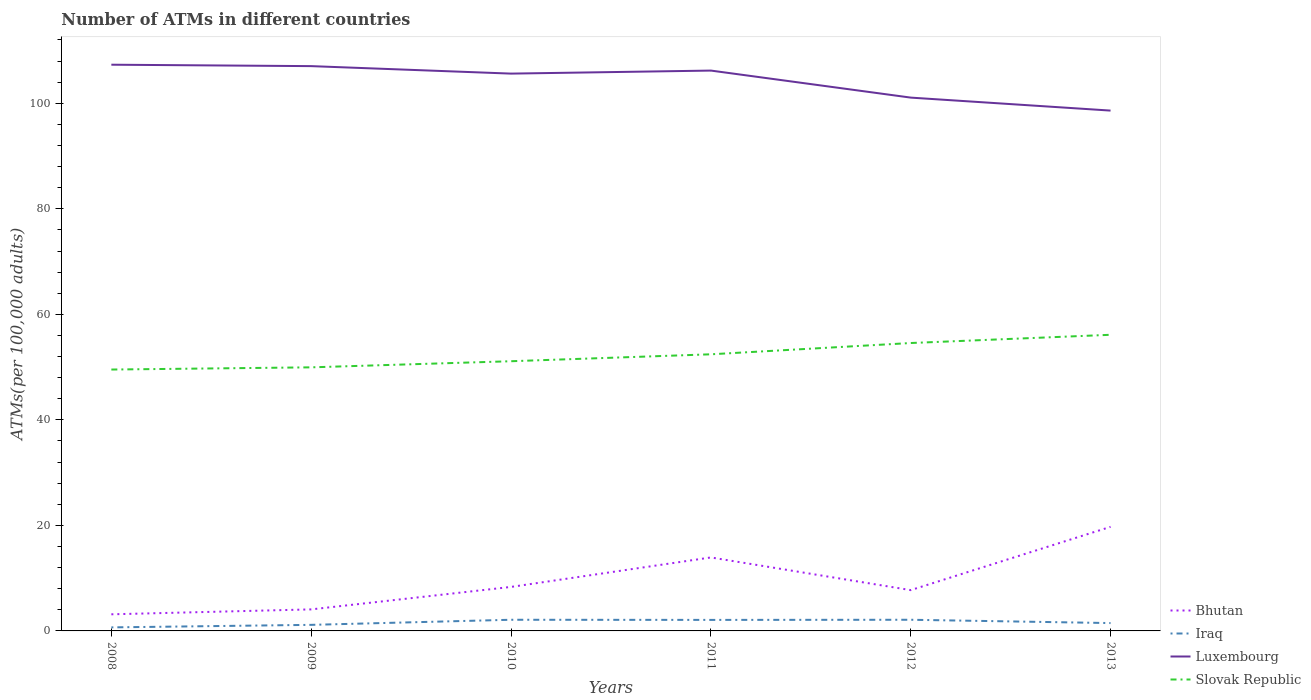How many different coloured lines are there?
Make the answer very short. 4. Does the line corresponding to Bhutan intersect with the line corresponding to Iraq?
Your answer should be very brief. No. Is the number of lines equal to the number of legend labels?
Give a very brief answer. Yes. Across all years, what is the maximum number of ATMs in Iraq?
Your response must be concise. 0.67. What is the total number of ATMs in Bhutan in the graph?
Your response must be concise. -11.39. What is the difference between the highest and the second highest number of ATMs in Iraq?
Make the answer very short. 1.45. Is the number of ATMs in Luxembourg strictly greater than the number of ATMs in Iraq over the years?
Keep it short and to the point. No. How many years are there in the graph?
Your answer should be compact. 6. Does the graph contain any zero values?
Give a very brief answer. No. Does the graph contain grids?
Provide a succinct answer. No. What is the title of the graph?
Give a very brief answer. Number of ATMs in different countries. Does "Italy" appear as one of the legend labels in the graph?
Ensure brevity in your answer.  No. What is the label or title of the X-axis?
Provide a short and direct response. Years. What is the label or title of the Y-axis?
Your response must be concise. ATMs(per 100,0 adults). What is the ATMs(per 100,000 adults) in Bhutan in 2008?
Offer a very short reply. 3.15. What is the ATMs(per 100,000 adults) in Iraq in 2008?
Provide a short and direct response. 0.67. What is the ATMs(per 100,000 adults) in Luxembourg in 2008?
Give a very brief answer. 107.32. What is the ATMs(per 100,000 adults) of Slovak Republic in 2008?
Offer a terse response. 49.54. What is the ATMs(per 100,000 adults) in Bhutan in 2009?
Your answer should be very brief. 4.08. What is the ATMs(per 100,000 adults) of Iraq in 2009?
Provide a succinct answer. 1.15. What is the ATMs(per 100,000 adults) of Luxembourg in 2009?
Your answer should be compact. 107.05. What is the ATMs(per 100,000 adults) in Slovak Republic in 2009?
Your answer should be very brief. 49.96. What is the ATMs(per 100,000 adults) in Bhutan in 2010?
Offer a very short reply. 8.34. What is the ATMs(per 100,000 adults) in Iraq in 2010?
Make the answer very short. 2.12. What is the ATMs(per 100,000 adults) of Luxembourg in 2010?
Keep it short and to the point. 105.63. What is the ATMs(per 100,000 adults) in Slovak Republic in 2010?
Provide a short and direct response. 51.12. What is the ATMs(per 100,000 adults) of Bhutan in 2011?
Provide a succinct answer. 13.93. What is the ATMs(per 100,000 adults) of Iraq in 2011?
Keep it short and to the point. 2.09. What is the ATMs(per 100,000 adults) in Luxembourg in 2011?
Make the answer very short. 106.2. What is the ATMs(per 100,000 adults) of Slovak Republic in 2011?
Your answer should be compact. 52.43. What is the ATMs(per 100,000 adults) in Bhutan in 2012?
Your answer should be very brief. 7.73. What is the ATMs(per 100,000 adults) in Iraq in 2012?
Your answer should be very brief. 2.12. What is the ATMs(per 100,000 adults) of Luxembourg in 2012?
Your response must be concise. 101.08. What is the ATMs(per 100,000 adults) in Slovak Republic in 2012?
Keep it short and to the point. 54.57. What is the ATMs(per 100,000 adults) in Bhutan in 2013?
Provide a short and direct response. 19.73. What is the ATMs(per 100,000 adults) in Iraq in 2013?
Provide a succinct answer. 1.49. What is the ATMs(per 100,000 adults) of Luxembourg in 2013?
Offer a very short reply. 98.62. What is the ATMs(per 100,000 adults) in Slovak Republic in 2013?
Your answer should be very brief. 56.13. Across all years, what is the maximum ATMs(per 100,000 adults) in Bhutan?
Give a very brief answer. 19.73. Across all years, what is the maximum ATMs(per 100,000 adults) of Iraq?
Give a very brief answer. 2.12. Across all years, what is the maximum ATMs(per 100,000 adults) in Luxembourg?
Provide a succinct answer. 107.32. Across all years, what is the maximum ATMs(per 100,000 adults) of Slovak Republic?
Ensure brevity in your answer.  56.13. Across all years, what is the minimum ATMs(per 100,000 adults) in Bhutan?
Your response must be concise. 3.15. Across all years, what is the minimum ATMs(per 100,000 adults) of Iraq?
Give a very brief answer. 0.67. Across all years, what is the minimum ATMs(per 100,000 adults) of Luxembourg?
Keep it short and to the point. 98.62. Across all years, what is the minimum ATMs(per 100,000 adults) in Slovak Republic?
Your response must be concise. 49.54. What is the total ATMs(per 100,000 adults) of Bhutan in the graph?
Provide a succinct answer. 56.96. What is the total ATMs(per 100,000 adults) of Iraq in the graph?
Give a very brief answer. 9.63. What is the total ATMs(per 100,000 adults) in Luxembourg in the graph?
Make the answer very short. 625.89. What is the total ATMs(per 100,000 adults) of Slovak Republic in the graph?
Provide a short and direct response. 313.74. What is the difference between the ATMs(per 100,000 adults) in Bhutan in 2008 and that in 2009?
Provide a succinct answer. -0.93. What is the difference between the ATMs(per 100,000 adults) in Iraq in 2008 and that in 2009?
Your response must be concise. -0.48. What is the difference between the ATMs(per 100,000 adults) of Luxembourg in 2008 and that in 2009?
Your answer should be very brief. 0.27. What is the difference between the ATMs(per 100,000 adults) of Slovak Republic in 2008 and that in 2009?
Your response must be concise. -0.42. What is the difference between the ATMs(per 100,000 adults) of Bhutan in 2008 and that in 2010?
Offer a terse response. -5.19. What is the difference between the ATMs(per 100,000 adults) of Iraq in 2008 and that in 2010?
Offer a very short reply. -1.45. What is the difference between the ATMs(per 100,000 adults) in Luxembourg in 2008 and that in 2010?
Your answer should be very brief. 1.69. What is the difference between the ATMs(per 100,000 adults) in Slovak Republic in 2008 and that in 2010?
Make the answer very short. -1.58. What is the difference between the ATMs(per 100,000 adults) in Bhutan in 2008 and that in 2011?
Make the answer very short. -10.78. What is the difference between the ATMs(per 100,000 adults) in Iraq in 2008 and that in 2011?
Your response must be concise. -1.42. What is the difference between the ATMs(per 100,000 adults) in Slovak Republic in 2008 and that in 2011?
Offer a terse response. -2.89. What is the difference between the ATMs(per 100,000 adults) of Bhutan in 2008 and that in 2012?
Provide a short and direct response. -4.58. What is the difference between the ATMs(per 100,000 adults) in Iraq in 2008 and that in 2012?
Provide a short and direct response. -1.45. What is the difference between the ATMs(per 100,000 adults) in Luxembourg in 2008 and that in 2012?
Offer a very short reply. 6.24. What is the difference between the ATMs(per 100,000 adults) of Slovak Republic in 2008 and that in 2012?
Provide a short and direct response. -5.03. What is the difference between the ATMs(per 100,000 adults) of Bhutan in 2008 and that in 2013?
Make the answer very short. -16.58. What is the difference between the ATMs(per 100,000 adults) in Iraq in 2008 and that in 2013?
Make the answer very short. -0.82. What is the difference between the ATMs(per 100,000 adults) in Luxembourg in 2008 and that in 2013?
Offer a very short reply. 8.7. What is the difference between the ATMs(per 100,000 adults) in Slovak Republic in 2008 and that in 2013?
Provide a succinct answer. -6.59. What is the difference between the ATMs(per 100,000 adults) of Bhutan in 2009 and that in 2010?
Give a very brief answer. -4.26. What is the difference between the ATMs(per 100,000 adults) in Iraq in 2009 and that in 2010?
Give a very brief answer. -0.97. What is the difference between the ATMs(per 100,000 adults) in Luxembourg in 2009 and that in 2010?
Make the answer very short. 1.42. What is the difference between the ATMs(per 100,000 adults) in Slovak Republic in 2009 and that in 2010?
Keep it short and to the point. -1.16. What is the difference between the ATMs(per 100,000 adults) in Bhutan in 2009 and that in 2011?
Your response must be concise. -9.84. What is the difference between the ATMs(per 100,000 adults) in Iraq in 2009 and that in 2011?
Offer a terse response. -0.94. What is the difference between the ATMs(per 100,000 adults) in Luxembourg in 2009 and that in 2011?
Make the answer very short. 0.84. What is the difference between the ATMs(per 100,000 adults) of Slovak Republic in 2009 and that in 2011?
Make the answer very short. -2.47. What is the difference between the ATMs(per 100,000 adults) in Bhutan in 2009 and that in 2012?
Offer a very short reply. -3.65. What is the difference between the ATMs(per 100,000 adults) in Iraq in 2009 and that in 2012?
Ensure brevity in your answer.  -0.97. What is the difference between the ATMs(per 100,000 adults) in Luxembourg in 2009 and that in 2012?
Provide a short and direct response. 5.97. What is the difference between the ATMs(per 100,000 adults) in Slovak Republic in 2009 and that in 2012?
Your response must be concise. -4.61. What is the difference between the ATMs(per 100,000 adults) in Bhutan in 2009 and that in 2013?
Your answer should be very brief. -15.65. What is the difference between the ATMs(per 100,000 adults) in Iraq in 2009 and that in 2013?
Offer a terse response. -0.34. What is the difference between the ATMs(per 100,000 adults) in Luxembourg in 2009 and that in 2013?
Your response must be concise. 8.43. What is the difference between the ATMs(per 100,000 adults) in Slovak Republic in 2009 and that in 2013?
Provide a short and direct response. -6.17. What is the difference between the ATMs(per 100,000 adults) of Bhutan in 2010 and that in 2011?
Ensure brevity in your answer.  -5.59. What is the difference between the ATMs(per 100,000 adults) of Iraq in 2010 and that in 2011?
Offer a very short reply. 0.03. What is the difference between the ATMs(per 100,000 adults) of Luxembourg in 2010 and that in 2011?
Your answer should be very brief. -0.58. What is the difference between the ATMs(per 100,000 adults) in Slovak Republic in 2010 and that in 2011?
Your response must be concise. -1.31. What is the difference between the ATMs(per 100,000 adults) in Bhutan in 2010 and that in 2012?
Ensure brevity in your answer.  0.61. What is the difference between the ATMs(per 100,000 adults) in Luxembourg in 2010 and that in 2012?
Your response must be concise. 4.55. What is the difference between the ATMs(per 100,000 adults) of Slovak Republic in 2010 and that in 2012?
Keep it short and to the point. -3.45. What is the difference between the ATMs(per 100,000 adults) in Bhutan in 2010 and that in 2013?
Ensure brevity in your answer.  -11.39. What is the difference between the ATMs(per 100,000 adults) of Iraq in 2010 and that in 2013?
Make the answer very short. 0.63. What is the difference between the ATMs(per 100,000 adults) of Luxembourg in 2010 and that in 2013?
Make the answer very short. 7.01. What is the difference between the ATMs(per 100,000 adults) of Slovak Republic in 2010 and that in 2013?
Your response must be concise. -5.01. What is the difference between the ATMs(per 100,000 adults) of Bhutan in 2011 and that in 2012?
Keep it short and to the point. 6.19. What is the difference between the ATMs(per 100,000 adults) of Iraq in 2011 and that in 2012?
Your response must be concise. -0.03. What is the difference between the ATMs(per 100,000 adults) in Luxembourg in 2011 and that in 2012?
Keep it short and to the point. 5.12. What is the difference between the ATMs(per 100,000 adults) of Slovak Republic in 2011 and that in 2012?
Provide a succinct answer. -2.14. What is the difference between the ATMs(per 100,000 adults) in Bhutan in 2011 and that in 2013?
Your answer should be very brief. -5.8. What is the difference between the ATMs(per 100,000 adults) in Iraq in 2011 and that in 2013?
Offer a very short reply. 0.6. What is the difference between the ATMs(per 100,000 adults) of Luxembourg in 2011 and that in 2013?
Make the answer very short. 7.58. What is the difference between the ATMs(per 100,000 adults) of Slovak Republic in 2011 and that in 2013?
Your answer should be compact. -3.7. What is the difference between the ATMs(per 100,000 adults) of Bhutan in 2012 and that in 2013?
Your answer should be very brief. -11.99. What is the difference between the ATMs(per 100,000 adults) in Iraq in 2012 and that in 2013?
Ensure brevity in your answer.  0.63. What is the difference between the ATMs(per 100,000 adults) of Luxembourg in 2012 and that in 2013?
Provide a short and direct response. 2.46. What is the difference between the ATMs(per 100,000 adults) in Slovak Republic in 2012 and that in 2013?
Your answer should be compact. -1.56. What is the difference between the ATMs(per 100,000 adults) in Bhutan in 2008 and the ATMs(per 100,000 adults) in Luxembourg in 2009?
Offer a terse response. -103.9. What is the difference between the ATMs(per 100,000 adults) in Bhutan in 2008 and the ATMs(per 100,000 adults) in Slovak Republic in 2009?
Give a very brief answer. -46.81. What is the difference between the ATMs(per 100,000 adults) of Iraq in 2008 and the ATMs(per 100,000 adults) of Luxembourg in 2009?
Offer a terse response. -106.38. What is the difference between the ATMs(per 100,000 adults) of Iraq in 2008 and the ATMs(per 100,000 adults) of Slovak Republic in 2009?
Provide a short and direct response. -49.29. What is the difference between the ATMs(per 100,000 adults) of Luxembourg in 2008 and the ATMs(per 100,000 adults) of Slovak Republic in 2009?
Make the answer very short. 57.36. What is the difference between the ATMs(per 100,000 adults) of Bhutan in 2008 and the ATMs(per 100,000 adults) of Iraq in 2010?
Your response must be concise. 1.03. What is the difference between the ATMs(per 100,000 adults) in Bhutan in 2008 and the ATMs(per 100,000 adults) in Luxembourg in 2010?
Keep it short and to the point. -102.48. What is the difference between the ATMs(per 100,000 adults) in Bhutan in 2008 and the ATMs(per 100,000 adults) in Slovak Republic in 2010?
Give a very brief answer. -47.97. What is the difference between the ATMs(per 100,000 adults) of Iraq in 2008 and the ATMs(per 100,000 adults) of Luxembourg in 2010?
Make the answer very short. -104.96. What is the difference between the ATMs(per 100,000 adults) in Iraq in 2008 and the ATMs(per 100,000 adults) in Slovak Republic in 2010?
Ensure brevity in your answer.  -50.45. What is the difference between the ATMs(per 100,000 adults) in Luxembourg in 2008 and the ATMs(per 100,000 adults) in Slovak Republic in 2010?
Your response must be concise. 56.2. What is the difference between the ATMs(per 100,000 adults) in Bhutan in 2008 and the ATMs(per 100,000 adults) in Iraq in 2011?
Provide a succinct answer. 1.06. What is the difference between the ATMs(per 100,000 adults) of Bhutan in 2008 and the ATMs(per 100,000 adults) of Luxembourg in 2011?
Give a very brief answer. -103.05. What is the difference between the ATMs(per 100,000 adults) in Bhutan in 2008 and the ATMs(per 100,000 adults) in Slovak Republic in 2011?
Provide a short and direct response. -49.28. What is the difference between the ATMs(per 100,000 adults) in Iraq in 2008 and the ATMs(per 100,000 adults) in Luxembourg in 2011?
Your answer should be compact. -105.53. What is the difference between the ATMs(per 100,000 adults) in Iraq in 2008 and the ATMs(per 100,000 adults) in Slovak Republic in 2011?
Make the answer very short. -51.76. What is the difference between the ATMs(per 100,000 adults) of Luxembourg in 2008 and the ATMs(per 100,000 adults) of Slovak Republic in 2011?
Ensure brevity in your answer.  54.89. What is the difference between the ATMs(per 100,000 adults) of Bhutan in 2008 and the ATMs(per 100,000 adults) of Iraq in 2012?
Keep it short and to the point. 1.03. What is the difference between the ATMs(per 100,000 adults) of Bhutan in 2008 and the ATMs(per 100,000 adults) of Luxembourg in 2012?
Give a very brief answer. -97.93. What is the difference between the ATMs(per 100,000 adults) of Bhutan in 2008 and the ATMs(per 100,000 adults) of Slovak Republic in 2012?
Your response must be concise. -51.42. What is the difference between the ATMs(per 100,000 adults) in Iraq in 2008 and the ATMs(per 100,000 adults) in Luxembourg in 2012?
Offer a very short reply. -100.41. What is the difference between the ATMs(per 100,000 adults) in Iraq in 2008 and the ATMs(per 100,000 adults) in Slovak Republic in 2012?
Your response must be concise. -53.9. What is the difference between the ATMs(per 100,000 adults) in Luxembourg in 2008 and the ATMs(per 100,000 adults) in Slovak Republic in 2012?
Provide a short and direct response. 52.75. What is the difference between the ATMs(per 100,000 adults) in Bhutan in 2008 and the ATMs(per 100,000 adults) in Iraq in 2013?
Your answer should be compact. 1.66. What is the difference between the ATMs(per 100,000 adults) in Bhutan in 2008 and the ATMs(per 100,000 adults) in Luxembourg in 2013?
Ensure brevity in your answer.  -95.47. What is the difference between the ATMs(per 100,000 adults) in Bhutan in 2008 and the ATMs(per 100,000 adults) in Slovak Republic in 2013?
Make the answer very short. -52.98. What is the difference between the ATMs(per 100,000 adults) of Iraq in 2008 and the ATMs(per 100,000 adults) of Luxembourg in 2013?
Provide a short and direct response. -97.95. What is the difference between the ATMs(per 100,000 adults) of Iraq in 2008 and the ATMs(per 100,000 adults) of Slovak Republic in 2013?
Your response must be concise. -55.46. What is the difference between the ATMs(per 100,000 adults) of Luxembourg in 2008 and the ATMs(per 100,000 adults) of Slovak Republic in 2013?
Offer a terse response. 51.19. What is the difference between the ATMs(per 100,000 adults) of Bhutan in 2009 and the ATMs(per 100,000 adults) of Iraq in 2010?
Keep it short and to the point. 1.97. What is the difference between the ATMs(per 100,000 adults) of Bhutan in 2009 and the ATMs(per 100,000 adults) of Luxembourg in 2010?
Provide a succinct answer. -101.55. What is the difference between the ATMs(per 100,000 adults) of Bhutan in 2009 and the ATMs(per 100,000 adults) of Slovak Republic in 2010?
Your answer should be compact. -47.03. What is the difference between the ATMs(per 100,000 adults) of Iraq in 2009 and the ATMs(per 100,000 adults) of Luxembourg in 2010?
Offer a very short reply. -104.48. What is the difference between the ATMs(per 100,000 adults) in Iraq in 2009 and the ATMs(per 100,000 adults) in Slovak Republic in 2010?
Give a very brief answer. -49.97. What is the difference between the ATMs(per 100,000 adults) in Luxembourg in 2009 and the ATMs(per 100,000 adults) in Slovak Republic in 2010?
Ensure brevity in your answer.  55.93. What is the difference between the ATMs(per 100,000 adults) in Bhutan in 2009 and the ATMs(per 100,000 adults) in Iraq in 2011?
Provide a short and direct response. 1.99. What is the difference between the ATMs(per 100,000 adults) of Bhutan in 2009 and the ATMs(per 100,000 adults) of Luxembourg in 2011?
Offer a terse response. -102.12. What is the difference between the ATMs(per 100,000 adults) of Bhutan in 2009 and the ATMs(per 100,000 adults) of Slovak Republic in 2011?
Provide a succinct answer. -48.35. What is the difference between the ATMs(per 100,000 adults) of Iraq in 2009 and the ATMs(per 100,000 adults) of Luxembourg in 2011?
Give a very brief answer. -105.05. What is the difference between the ATMs(per 100,000 adults) in Iraq in 2009 and the ATMs(per 100,000 adults) in Slovak Republic in 2011?
Your answer should be very brief. -51.28. What is the difference between the ATMs(per 100,000 adults) of Luxembourg in 2009 and the ATMs(per 100,000 adults) of Slovak Republic in 2011?
Offer a terse response. 54.62. What is the difference between the ATMs(per 100,000 adults) in Bhutan in 2009 and the ATMs(per 100,000 adults) in Iraq in 2012?
Offer a very short reply. 1.97. What is the difference between the ATMs(per 100,000 adults) of Bhutan in 2009 and the ATMs(per 100,000 adults) of Luxembourg in 2012?
Keep it short and to the point. -97. What is the difference between the ATMs(per 100,000 adults) of Bhutan in 2009 and the ATMs(per 100,000 adults) of Slovak Republic in 2012?
Provide a short and direct response. -50.48. What is the difference between the ATMs(per 100,000 adults) of Iraq in 2009 and the ATMs(per 100,000 adults) of Luxembourg in 2012?
Give a very brief answer. -99.93. What is the difference between the ATMs(per 100,000 adults) of Iraq in 2009 and the ATMs(per 100,000 adults) of Slovak Republic in 2012?
Offer a very short reply. -53.42. What is the difference between the ATMs(per 100,000 adults) in Luxembourg in 2009 and the ATMs(per 100,000 adults) in Slovak Republic in 2012?
Ensure brevity in your answer.  52.48. What is the difference between the ATMs(per 100,000 adults) in Bhutan in 2009 and the ATMs(per 100,000 adults) in Iraq in 2013?
Ensure brevity in your answer.  2.59. What is the difference between the ATMs(per 100,000 adults) of Bhutan in 2009 and the ATMs(per 100,000 adults) of Luxembourg in 2013?
Your answer should be compact. -94.54. What is the difference between the ATMs(per 100,000 adults) in Bhutan in 2009 and the ATMs(per 100,000 adults) in Slovak Republic in 2013?
Provide a succinct answer. -52.05. What is the difference between the ATMs(per 100,000 adults) in Iraq in 2009 and the ATMs(per 100,000 adults) in Luxembourg in 2013?
Keep it short and to the point. -97.47. What is the difference between the ATMs(per 100,000 adults) of Iraq in 2009 and the ATMs(per 100,000 adults) of Slovak Republic in 2013?
Offer a very short reply. -54.98. What is the difference between the ATMs(per 100,000 adults) in Luxembourg in 2009 and the ATMs(per 100,000 adults) in Slovak Republic in 2013?
Your answer should be very brief. 50.92. What is the difference between the ATMs(per 100,000 adults) in Bhutan in 2010 and the ATMs(per 100,000 adults) in Iraq in 2011?
Ensure brevity in your answer.  6.25. What is the difference between the ATMs(per 100,000 adults) of Bhutan in 2010 and the ATMs(per 100,000 adults) of Luxembourg in 2011?
Your response must be concise. -97.86. What is the difference between the ATMs(per 100,000 adults) in Bhutan in 2010 and the ATMs(per 100,000 adults) in Slovak Republic in 2011?
Offer a terse response. -44.09. What is the difference between the ATMs(per 100,000 adults) in Iraq in 2010 and the ATMs(per 100,000 adults) in Luxembourg in 2011?
Your response must be concise. -104.09. What is the difference between the ATMs(per 100,000 adults) of Iraq in 2010 and the ATMs(per 100,000 adults) of Slovak Republic in 2011?
Offer a terse response. -50.31. What is the difference between the ATMs(per 100,000 adults) in Luxembourg in 2010 and the ATMs(per 100,000 adults) in Slovak Republic in 2011?
Provide a succinct answer. 53.2. What is the difference between the ATMs(per 100,000 adults) of Bhutan in 2010 and the ATMs(per 100,000 adults) of Iraq in 2012?
Offer a very short reply. 6.22. What is the difference between the ATMs(per 100,000 adults) of Bhutan in 2010 and the ATMs(per 100,000 adults) of Luxembourg in 2012?
Your answer should be very brief. -92.74. What is the difference between the ATMs(per 100,000 adults) in Bhutan in 2010 and the ATMs(per 100,000 adults) in Slovak Republic in 2012?
Your response must be concise. -46.23. What is the difference between the ATMs(per 100,000 adults) in Iraq in 2010 and the ATMs(per 100,000 adults) in Luxembourg in 2012?
Give a very brief answer. -98.96. What is the difference between the ATMs(per 100,000 adults) in Iraq in 2010 and the ATMs(per 100,000 adults) in Slovak Republic in 2012?
Offer a terse response. -52.45. What is the difference between the ATMs(per 100,000 adults) in Luxembourg in 2010 and the ATMs(per 100,000 adults) in Slovak Republic in 2012?
Keep it short and to the point. 51.06. What is the difference between the ATMs(per 100,000 adults) of Bhutan in 2010 and the ATMs(per 100,000 adults) of Iraq in 2013?
Make the answer very short. 6.85. What is the difference between the ATMs(per 100,000 adults) in Bhutan in 2010 and the ATMs(per 100,000 adults) in Luxembourg in 2013?
Make the answer very short. -90.28. What is the difference between the ATMs(per 100,000 adults) in Bhutan in 2010 and the ATMs(per 100,000 adults) in Slovak Republic in 2013?
Your answer should be very brief. -47.79. What is the difference between the ATMs(per 100,000 adults) in Iraq in 2010 and the ATMs(per 100,000 adults) in Luxembourg in 2013?
Make the answer very short. -96.5. What is the difference between the ATMs(per 100,000 adults) of Iraq in 2010 and the ATMs(per 100,000 adults) of Slovak Republic in 2013?
Offer a very short reply. -54.01. What is the difference between the ATMs(per 100,000 adults) in Luxembourg in 2010 and the ATMs(per 100,000 adults) in Slovak Republic in 2013?
Give a very brief answer. 49.5. What is the difference between the ATMs(per 100,000 adults) in Bhutan in 2011 and the ATMs(per 100,000 adults) in Iraq in 2012?
Offer a very short reply. 11.81. What is the difference between the ATMs(per 100,000 adults) of Bhutan in 2011 and the ATMs(per 100,000 adults) of Luxembourg in 2012?
Provide a succinct answer. -87.15. What is the difference between the ATMs(per 100,000 adults) in Bhutan in 2011 and the ATMs(per 100,000 adults) in Slovak Republic in 2012?
Your answer should be very brief. -40.64. What is the difference between the ATMs(per 100,000 adults) of Iraq in 2011 and the ATMs(per 100,000 adults) of Luxembourg in 2012?
Your answer should be very brief. -98.99. What is the difference between the ATMs(per 100,000 adults) of Iraq in 2011 and the ATMs(per 100,000 adults) of Slovak Republic in 2012?
Ensure brevity in your answer.  -52.48. What is the difference between the ATMs(per 100,000 adults) in Luxembourg in 2011 and the ATMs(per 100,000 adults) in Slovak Republic in 2012?
Your answer should be compact. 51.64. What is the difference between the ATMs(per 100,000 adults) of Bhutan in 2011 and the ATMs(per 100,000 adults) of Iraq in 2013?
Your answer should be compact. 12.44. What is the difference between the ATMs(per 100,000 adults) of Bhutan in 2011 and the ATMs(per 100,000 adults) of Luxembourg in 2013?
Your answer should be very brief. -84.69. What is the difference between the ATMs(per 100,000 adults) in Bhutan in 2011 and the ATMs(per 100,000 adults) in Slovak Republic in 2013?
Make the answer very short. -42.2. What is the difference between the ATMs(per 100,000 adults) of Iraq in 2011 and the ATMs(per 100,000 adults) of Luxembourg in 2013?
Your response must be concise. -96.53. What is the difference between the ATMs(per 100,000 adults) in Iraq in 2011 and the ATMs(per 100,000 adults) in Slovak Republic in 2013?
Provide a succinct answer. -54.04. What is the difference between the ATMs(per 100,000 adults) in Luxembourg in 2011 and the ATMs(per 100,000 adults) in Slovak Republic in 2013?
Keep it short and to the point. 50.08. What is the difference between the ATMs(per 100,000 adults) of Bhutan in 2012 and the ATMs(per 100,000 adults) of Iraq in 2013?
Your answer should be compact. 6.25. What is the difference between the ATMs(per 100,000 adults) in Bhutan in 2012 and the ATMs(per 100,000 adults) in Luxembourg in 2013?
Provide a succinct answer. -90.89. What is the difference between the ATMs(per 100,000 adults) in Bhutan in 2012 and the ATMs(per 100,000 adults) in Slovak Republic in 2013?
Offer a terse response. -48.39. What is the difference between the ATMs(per 100,000 adults) in Iraq in 2012 and the ATMs(per 100,000 adults) in Luxembourg in 2013?
Make the answer very short. -96.5. What is the difference between the ATMs(per 100,000 adults) of Iraq in 2012 and the ATMs(per 100,000 adults) of Slovak Republic in 2013?
Your answer should be compact. -54.01. What is the difference between the ATMs(per 100,000 adults) in Luxembourg in 2012 and the ATMs(per 100,000 adults) in Slovak Republic in 2013?
Offer a terse response. 44.95. What is the average ATMs(per 100,000 adults) of Bhutan per year?
Keep it short and to the point. 9.49. What is the average ATMs(per 100,000 adults) in Iraq per year?
Provide a succinct answer. 1.6. What is the average ATMs(per 100,000 adults) in Luxembourg per year?
Your answer should be compact. 104.32. What is the average ATMs(per 100,000 adults) in Slovak Republic per year?
Ensure brevity in your answer.  52.29. In the year 2008, what is the difference between the ATMs(per 100,000 adults) of Bhutan and ATMs(per 100,000 adults) of Iraq?
Your answer should be very brief. 2.48. In the year 2008, what is the difference between the ATMs(per 100,000 adults) of Bhutan and ATMs(per 100,000 adults) of Luxembourg?
Make the answer very short. -104.17. In the year 2008, what is the difference between the ATMs(per 100,000 adults) of Bhutan and ATMs(per 100,000 adults) of Slovak Republic?
Offer a very short reply. -46.39. In the year 2008, what is the difference between the ATMs(per 100,000 adults) in Iraq and ATMs(per 100,000 adults) in Luxembourg?
Make the answer very short. -106.65. In the year 2008, what is the difference between the ATMs(per 100,000 adults) of Iraq and ATMs(per 100,000 adults) of Slovak Republic?
Offer a terse response. -48.87. In the year 2008, what is the difference between the ATMs(per 100,000 adults) of Luxembourg and ATMs(per 100,000 adults) of Slovak Republic?
Provide a short and direct response. 57.78. In the year 2009, what is the difference between the ATMs(per 100,000 adults) of Bhutan and ATMs(per 100,000 adults) of Iraq?
Give a very brief answer. 2.93. In the year 2009, what is the difference between the ATMs(per 100,000 adults) of Bhutan and ATMs(per 100,000 adults) of Luxembourg?
Offer a very short reply. -102.96. In the year 2009, what is the difference between the ATMs(per 100,000 adults) of Bhutan and ATMs(per 100,000 adults) of Slovak Republic?
Offer a terse response. -45.88. In the year 2009, what is the difference between the ATMs(per 100,000 adults) in Iraq and ATMs(per 100,000 adults) in Luxembourg?
Offer a very short reply. -105.9. In the year 2009, what is the difference between the ATMs(per 100,000 adults) of Iraq and ATMs(per 100,000 adults) of Slovak Republic?
Provide a short and direct response. -48.81. In the year 2009, what is the difference between the ATMs(per 100,000 adults) of Luxembourg and ATMs(per 100,000 adults) of Slovak Republic?
Offer a terse response. 57.09. In the year 2010, what is the difference between the ATMs(per 100,000 adults) of Bhutan and ATMs(per 100,000 adults) of Iraq?
Make the answer very short. 6.22. In the year 2010, what is the difference between the ATMs(per 100,000 adults) in Bhutan and ATMs(per 100,000 adults) in Luxembourg?
Your response must be concise. -97.29. In the year 2010, what is the difference between the ATMs(per 100,000 adults) of Bhutan and ATMs(per 100,000 adults) of Slovak Republic?
Provide a succinct answer. -42.78. In the year 2010, what is the difference between the ATMs(per 100,000 adults) of Iraq and ATMs(per 100,000 adults) of Luxembourg?
Your answer should be compact. -103.51. In the year 2010, what is the difference between the ATMs(per 100,000 adults) in Iraq and ATMs(per 100,000 adults) in Slovak Republic?
Make the answer very short. -49. In the year 2010, what is the difference between the ATMs(per 100,000 adults) in Luxembourg and ATMs(per 100,000 adults) in Slovak Republic?
Keep it short and to the point. 54.51. In the year 2011, what is the difference between the ATMs(per 100,000 adults) of Bhutan and ATMs(per 100,000 adults) of Iraq?
Give a very brief answer. 11.84. In the year 2011, what is the difference between the ATMs(per 100,000 adults) in Bhutan and ATMs(per 100,000 adults) in Luxembourg?
Your response must be concise. -92.28. In the year 2011, what is the difference between the ATMs(per 100,000 adults) in Bhutan and ATMs(per 100,000 adults) in Slovak Republic?
Give a very brief answer. -38.5. In the year 2011, what is the difference between the ATMs(per 100,000 adults) of Iraq and ATMs(per 100,000 adults) of Luxembourg?
Your response must be concise. -104.12. In the year 2011, what is the difference between the ATMs(per 100,000 adults) in Iraq and ATMs(per 100,000 adults) in Slovak Republic?
Ensure brevity in your answer.  -50.34. In the year 2011, what is the difference between the ATMs(per 100,000 adults) of Luxembourg and ATMs(per 100,000 adults) of Slovak Republic?
Keep it short and to the point. 53.77. In the year 2012, what is the difference between the ATMs(per 100,000 adults) in Bhutan and ATMs(per 100,000 adults) in Iraq?
Make the answer very short. 5.62. In the year 2012, what is the difference between the ATMs(per 100,000 adults) of Bhutan and ATMs(per 100,000 adults) of Luxembourg?
Keep it short and to the point. -93.35. In the year 2012, what is the difference between the ATMs(per 100,000 adults) in Bhutan and ATMs(per 100,000 adults) in Slovak Republic?
Make the answer very short. -46.83. In the year 2012, what is the difference between the ATMs(per 100,000 adults) in Iraq and ATMs(per 100,000 adults) in Luxembourg?
Your response must be concise. -98.96. In the year 2012, what is the difference between the ATMs(per 100,000 adults) of Iraq and ATMs(per 100,000 adults) of Slovak Republic?
Provide a short and direct response. -52.45. In the year 2012, what is the difference between the ATMs(per 100,000 adults) of Luxembourg and ATMs(per 100,000 adults) of Slovak Republic?
Your answer should be compact. 46.51. In the year 2013, what is the difference between the ATMs(per 100,000 adults) in Bhutan and ATMs(per 100,000 adults) in Iraq?
Your response must be concise. 18.24. In the year 2013, what is the difference between the ATMs(per 100,000 adults) in Bhutan and ATMs(per 100,000 adults) in Luxembourg?
Keep it short and to the point. -78.89. In the year 2013, what is the difference between the ATMs(per 100,000 adults) of Bhutan and ATMs(per 100,000 adults) of Slovak Republic?
Provide a short and direct response. -36.4. In the year 2013, what is the difference between the ATMs(per 100,000 adults) of Iraq and ATMs(per 100,000 adults) of Luxembourg?
Provide a succinct answer. -97.13. In the year 2013, what is the difference between the ATMs(per 100,000 adults) of Iraq and ATMs(per 100,000 adults) of Slovak Republic?
Make the answer very short. -54.64. In the year 2013, what is the difference between the ATMs(per 100,000 adults) in Luxembourg and ATMs(per 100,000 adults) in Slovak Republic?
Provide a short and direct response. 42.49. What is the ratio of the ATMs(per 100,000 adults) in Bhutan in 2008 to that in 2009?
Offer a very short reply. 0.77. What is the ratio of the ATMs(per 100,000 adults) in Iraq in 2008 to that in 2009?
Provide a short and direct response. 0.58. What is the ratio of the ATMs(per 100,000 adults) in Luxembourg in 2008 to that in 2009?
Ensure brevity in your answer.  1. What is the ratio of the ATMs(per 100,000 adults) in Bhutan in 2008 to that in 2010?
Your answer should be compact. 0.38. What is the ratio of the ATMs(per 100,000 adults) of Iraq in 2008 to that in 2010?
Ensure brevity in your answer.  0.32. What is the ratio of the ATMs(per 100,000 adults) of Luxembourg in 2008 to that in 2010?
Provide a short and direct response. 1.02. What is the ratio of the ATMs(per 100,000 adults) in Slovak Republic in 2008 to that in 2010?
Your answer should be very brief. 0.97. What is the ratio of the ATMs(per 100,000 adults) in Bhutan in 2008 to that in 2011?
Your answer should be compact. 0.23. What is the ratio of the ATMs(per 100,000 adults) of Iraq in 2008 to that in 2011?
Provide a short and direct response. 0.32. What is the ratio of the ATMs(per 100,000 adults) in Luxembourg in 2008 to that in 2011?
Your answer should be compact. 1.01. What is the ratio of the ATMs(per 100,000 adults) of Slovak Republic in 2008 to that in 2011?
Offer a very short reply. 0.94. What is the ratio of the ATMs(per 100,000 adults) of Bhutan in 2008 to that in 2012?
Provide a succinct answer. 0.41. What is the ratio of the ATMs(per 100,000 adults) in Iraq in 2008 to that in 2012?
Ensure brevity in your answer.  0.32. What is the ratio of the ATMs(per 100,000 adults) in Luxembourg in 2008 to that in 2012?
Ensure brevity in your answer.  1.06. What is the ratio of the ATMs(per 100,000 adults) in Slovak Republic in 2008 to that in 2012?
Keep it short and to the point. 0.91. What is the ratio of the ATMs(per 100,000 adults) of Bhutan in 2008 to that in 2013?
Make the answer very short. 0.16. What is the ratio of the ATMs(per 100,000 adults) of Iraq in 2008 to that in 2013?
Provide a short and direct response. 0.45. What is the ratio of the ATMs(per 100,000 adults) in Luxembourg in 2008 to that in 2013?
Your response must be concise. 1.09. What is the ratio of the ATMs(per 100,000 adults) of Slovak Republic in 2008 to that in 2013?
Your answer should be compact. 0.88. What is the ratio of the ATMs(per 100,000 adults) of Bhutan in 2009 to that in 2010?
Your response must be concise. 0.49. What is the ratio of the ATMs(per 100,000 adults) in Iraq in 2009 to that in 2010?
Provide a short and direct response. 0.54. What is the ratio of the ATMs(per 100,000 adults) of Luxembourg in 2009 to that in 2010?
Give a very brief answer. 1.01. What is the ratio of the ATMs(per 100,000 adults) in Slovak Republic in 2009 to that in 2010?
Offer a very short reply. 0.98. What is the ratio of the ATMs(per 100,000 adults) of Bhutan in 2009 to that in 2011?
Your answer should be compact. 0.29. What is the ratio of the ATMs(per 100,000 adults) in Iraq in 2009 to that in 2011?
Provide a short and direct response. 0.55. What is the ratio of the ATMs(per 100,000 adults) in Luxembourg in 2009 to that in 2011?
Provide a succinct answer. 1.01. What is the ratio of the ATMs(per 100,000 adults) of Slovak Republic in 2009 to that in 2011?
Offer a very short reply. 0.95. What is the ratio of the ATMs(per 100,000 adults) of Bhutan in 2009 to that in 2012?
Offer a terse response. 0.53. What is the ratio of the ATMs(per 100,000 adults) in Iraq in 2009 to that in 2012?
Offer a very short reply. 0.54. What is the ratio of the ATMs(per 100,000 adults) in Luxembourg in 2009 to that in 2012?
Provide a succinct answer. 1.06. What is the ratio of the ATMs(per 100,000 adults) in Slovak Republic in 2009 to that in 2012?
Provide a short and direct response. 0.92. What is the ratio of the ATMs(per 100,000 adults) of Bhutan in 2009 to that in 2013?
Provide a succinct answer. 0.21. What is the ratio of the ATMs(per 100,000 adults) in Iraq in 2009 to that in 2013?
Your answer should be compact. 0.77. What is the ratio of the ATMs(per 100,000 adults) in Luxembourg in 2009 to that in 2013?
Your response must be concise. 1.09. What is the ratio of the ATMs(per 100,000 adults) in Slovak Republic in 2009 to that in 2013?
Provide a short and direct response. 0.89. What is the ratio of the ATMs(per 100,000 adults) in Bhutan in 2010 to that in 2011?
Provide a succinct answer. 0.6. What is the ratio of the ATMs(per 100,000 adults) in Iraq in 2010 to that in 2011?
Ensure brevity in your answer.  1.01. What is the ratio of the ATMs(per 100,000 adults) of Slovak Republic in 2010 to that in 2011?
Offer a very short reply. 0.97. What is the ratio of the ATMs(per 100,000 adults) of Bhutan in 2010 to that in 2012?
Keep it short and to the point. 1.08. What is the ratio of the ATMs(per 100,000 adults) of Iraq in 2010 to that in 2012?
Provide a short and direct response. 1. What is the ratio of the ATMs(per 100,000 adults) of Luxembourg in 2010 to that in 2012?
Give a very brief answer. 1.04. What is the ratio of the ATMs(per 100,000 adults) in Slovak Republic in 2010 to that in 2012?
Your answer should be very brief. 0.94. What is the ratio of the ATMs(per 100,000 adults) of Bhutan in 2010 to that in 2013?
Make the answer very short. 0.42. What is the ratio of the ATMs(per 100,000 adults) of Iraq in 2010 to that in 2013?
Make the answer very short. 1.42. What is the ratio of the ATMs(per 100,000 adults) of Luxembourg in 2010 to that in 2013?
Offer a terse response. 1.07. What is the ratio of the ATMs(per 100,000 adults) in Slovak Republic in 2010 to that in 2013?
Offer a terse response. 0.91. What is the ratio of the ATMs(per 100,000 adults) in Bhutan in 2011 to that in 2012?
Keep it short and to the point. 1.8. What is the ratio of the ATMs(per 100,000 adults) in Iraq in 2011 to that in 2012?
Your response must be concise. 0.99. What is the ratio of the ATMs(per 100,000 adults) in Luxembourg in 2011 to that in 2012?
Your answer should be compact. 1.05. What is the ratio of the ATMs(per 100,000 adults) of Slovak Republic in 2011 to that in 2012?
Offer a terse response. 0.96. What is the ratio of the ATMs(per 100,000 adults) of Bhutan in 2011 to that in 2013?
Ensure brevity in your answer.  0.71. What is the ratio of the ATMs(per 100,000 adults) of Iraq in 2011 to that in 2013?
Keep it short and to the point. 1.4. What is the ratio of the ATMs(per 100,000 adults) in Luxembourg in 2011 to that in 2013?
Make the answer very short. 1.08. What is the ratio of the ATMs(per 100,000 adults) of Slovak Republic in 2011 to that in 2013?
Your answer should be very brief. 0.93. What is the ratio of the ATMs(per 100,000 adults) of Bhutan in 2012 to that in 2013?
Ensure brevity in your answer.  0.39. What is the ratio of the ATMs(per 100,000 adults) in Iraq in 2012 to that in 2013?
Offer a very short reply. 1.42. What is the ratio of the ATMs(per 100,000 adults) in Luxembourg in 2012 to that in 2013?
Your answer should be compact. 1.02. What is the ratio of the ATMs(per 100,000 adults) in Slovak Republic in 2012 to that in 2013?
Provide a succinct answer. 0.97. What is the difference between the highest and the second highest ATMs(per 100,000 adults) of Bhutan?
Offer a very short reply. 5.8. What is the difference between the highest and the second highest ATMs(per 100,000 adults) of Iraq?
Your answer should be very brief. 0. What is the difference between the highest and the second highest ATMs(per 100,000 adults) of Luxembourg?
Ensure brevity in your answer.  0.27. What is the difference between the highest and the second highest ATMs(per 100,000 adults) in Slovak Republic?
Your answer should be compact. 1.56. What is the difference between the highest and the lowest ATMs(per 100,000 adults) of Bhutan?
Keep it short and to the point. 16.58. What is the difference between the highest and the lowest ATMs(per 100,000 adults) in Iraq?
Your answer should be very brief. 1.45. What is the difference between the highest and the lowest ATMs(per 100,000 adults) of Luxembourg?
Provide a short and direct response. 8.7. What is the difference between the highest and the lowest ATMs(per 100,000 adults) of Slovak Republic?
Give a very brief answer. 6.59. 